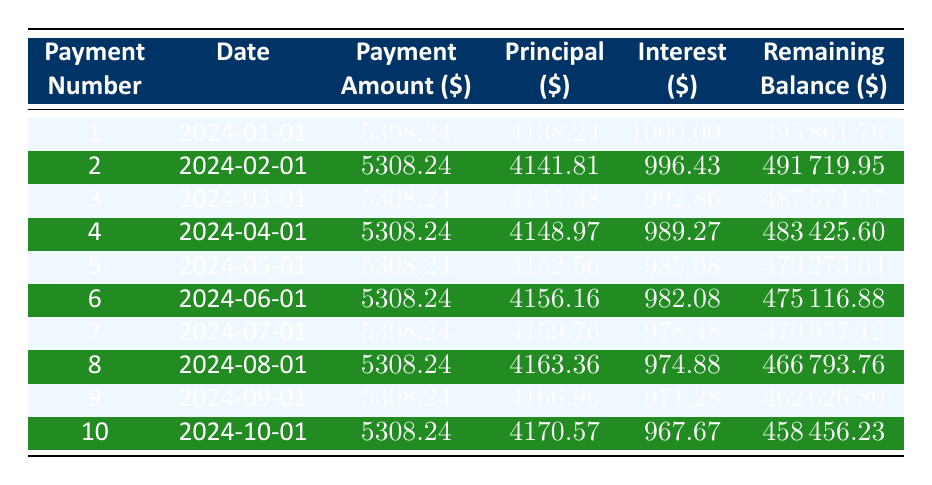What is the total amount paid in the first month? The total amount paid in the first month is specified in the "Payment Amount" column for payment number 1. It shows 5308.24.
Answer: 5308.24 How much of the payment in the second month goes towards the principal? The payment amount for the second month is 5308.24, and the principal portion for that payment is specifically stated as 4141.81.
Answer: 4141.81 Is the interest paid in the third month higher than in the first month? The interest for the third month is listed as 992.86 while the interest for the first month is 1000.00. Comparing these values shows that 992.86 is less than 1000.00.
Answer: No What is the total principal paid after the first 5 months? To find the total principal paid after the first 5 months, sum the principal amounts from the first five entries: 4138.24 + 4141.81 + 4145.38 + 4148.97 + 4152.56 = 20726.96.
Answer: 20726.96 What is the remaining balance after the 4th payment? The remaining balance after the 4th payment can be found in the "Remaining Balance" column for payment number 4, which shows 483425.60.
Answer: 483425.60 How much total interest will be paid in the first three months? To find the total interest paid in the first three months, sum the interest from the first three payments: 1000.00 + 996.43 + 992.86 = 2989.29.
Answer: 2989.29 Is the monthly payment consistent throughout the first 10 months? Each monthly payment amount for all ten payments is listed as 5308.24, indicating that it remains constant.
Answer: Yes What is the average principal repayment per month over the first 10 months? The total principal for the first 10 months is calculated by summing all the principal amounts and then dividing by 10: (4138.24 + 4141.81 + 4145.38 + 4148.97 + 4152.56 + 4156.16 + 4159.76 + 4163.36 + 4166.96 + 4170.57) / 10 = 4150.73.
Answer: 4150.73 What is the remaining balance after the 10th payment? The remaining balance after the 10th payment is found in the "Remaining Balance" column for payment number 10, which indicates 458456.23.
Answer: 458456.23 